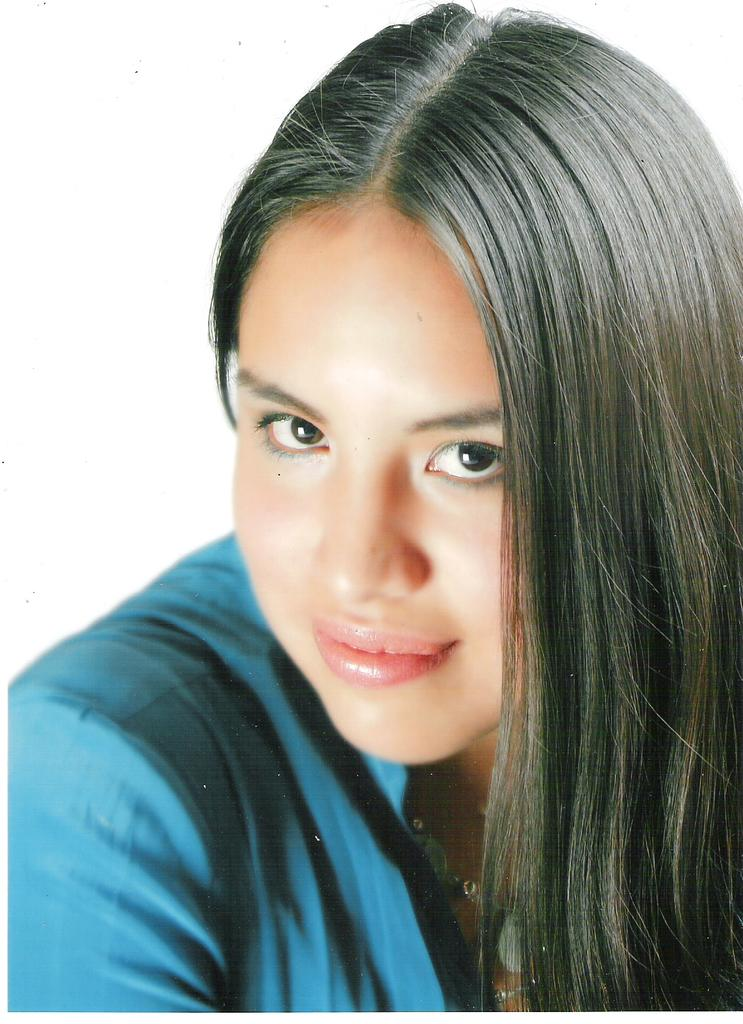What is the main subject of the image? The main subject of the image is a woman. What is the woman doing in the image? The woman is smiling in the image. What color is the top that the woman is wearing? The woman is wearing a blue top. What type of fireman is present in the image? There is no fireman present in the image; it features a woman smiling and wearing a blue top. How does the woman transport herself in the image? The image does not show the woman transporting herself; it only shows her standing and smiling. 